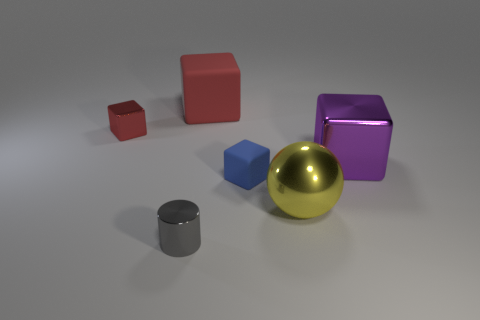Subtract all purple cubes. How many cubes are left? 3 Subtract all gray blocks. Subtract all green cylinders. How many blocks are left? 4 Add 2 big yellow cubes. How many objects exist? 8 Subtract all cubes. How many objects are left? 2 Subtract all large cyan cylinders. Subtract all small blue cubes. How many objects are left? 5 Add 3 red blocks. How many red blocks are left? 5 Add 2 cubes. How many cubes exist? 6 Subtract 1 blue blocks. How many objects are left? 5 